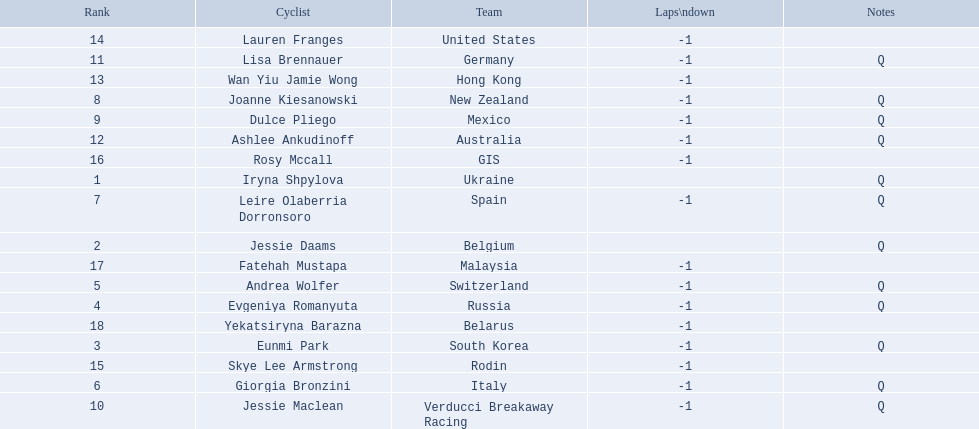Who are all of the cyclists in this race? Iryna Shpylova, Jessie Daams, Eunmi Park, Evgeniya Romanyuta, Andrea Wolfer, Giorgia Bronzini, Leire Olaberria Dorronsoro, Joanne Kiesanowski, Dulce Pliego, Jessie Maclean, Lisa Brennauer, Ashlee Ankudinoff, Wan Yiu Jamie Wong, Lauren Franges, Skye Lee Armstrong, Rosy Mccall, Fatehah Mustapa, Yekatsiryna Barazna. Of these, which one has the lowest numbered rank? Iryna Shpylova. 